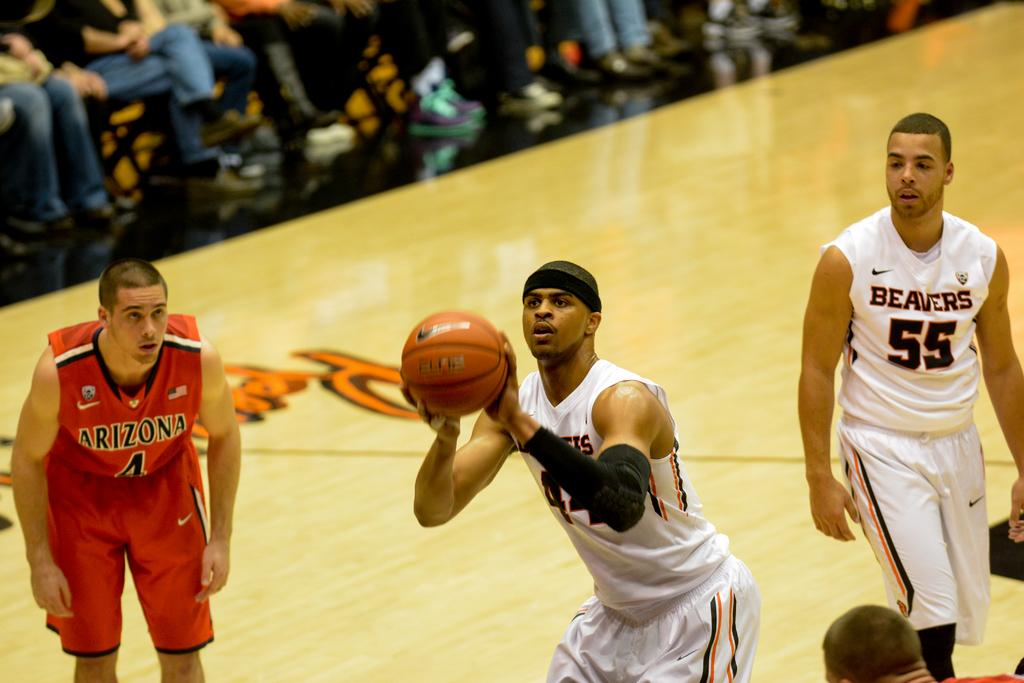<image>
Offer a succinct explanation of the picture presented. Beavers player number 55 looks on as his teammate shoots a free throw. 